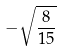Convert formula to latex. <formula><loc_0><loc_0><loc_500><loc_500>- \sqrt { \frac { 8 } { 1 5 } }</formula> 